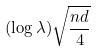<formula> <loc_0><loc_0><loc_500><loc_500>( \log \lambda ) \sqrt { \frac { n d } { 4 } }</formula> 